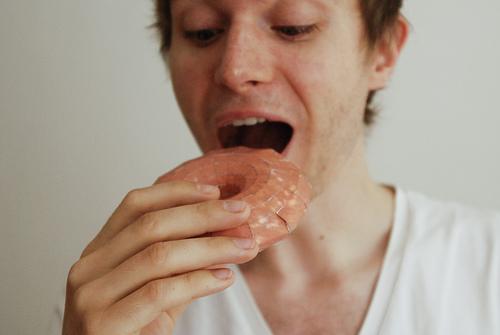Does this food product come in a wrapper?
Be succinct. No. What is the woman holding?
Quick response, please. Donut. With which hand is the boy eating?
Answer briefly. Right. What food is he eating?
Keep it brief. Donut. Is the guy looking forward to what he is about to eat?
Keep it brief. Yes. Is this a man or woman?
Short answer required. Man. What color is his shirt?
Quick response, please. White. Is it necessary for him to open his mouth this wide to eat this?
Concise answer only. Yes. 